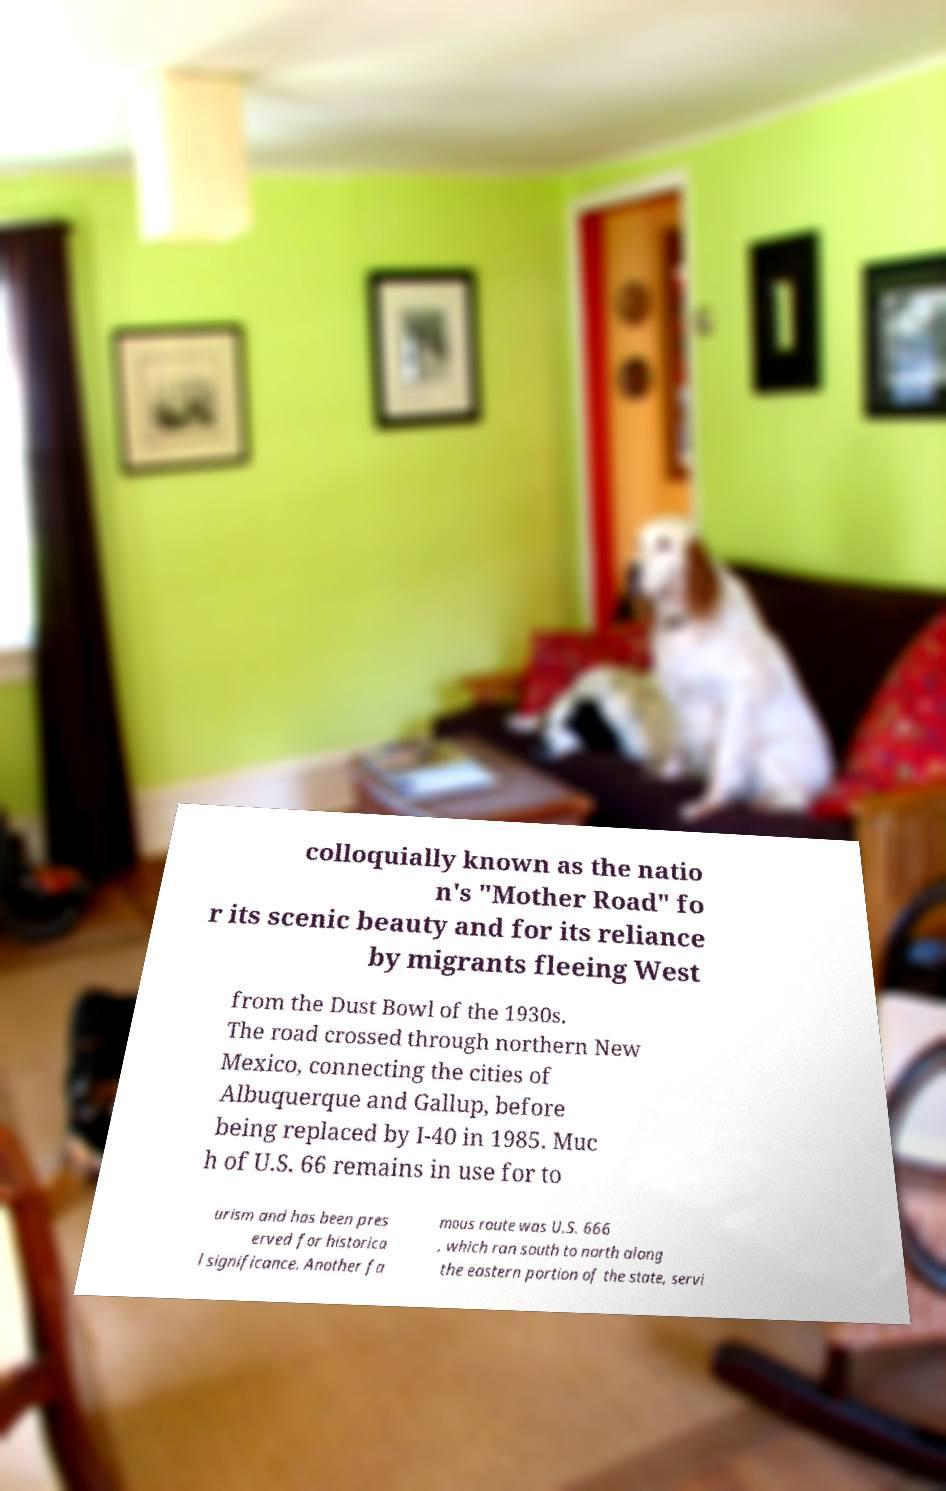There's text embedded in this image that I need extracted. Can you transcribe it verbatim? colloquially known as the natio n's "Mother Road" fo r its scenic beauty and for its reliance by migrants fleeing West from the Dust Bowl of the 1930s. The road crossed through northern New Mexico, connecting the cities of Albuquerque and Gallup, before being replaced by I-40 in 1985. Muc h of U.S. 66 remains in use for to urism and has been pres erved for historica l significance. Another fa mous route was U.S. 666 , which ran south to north along the eastern portion of the state, servi 